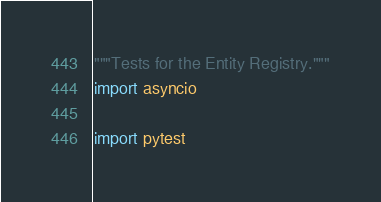Convert code to text. <code><loc_0><loc_0><loc_500><loc_500><_Python_>"""Tests for the Entity Registry."""
import asyncio

import pytest
</code> 